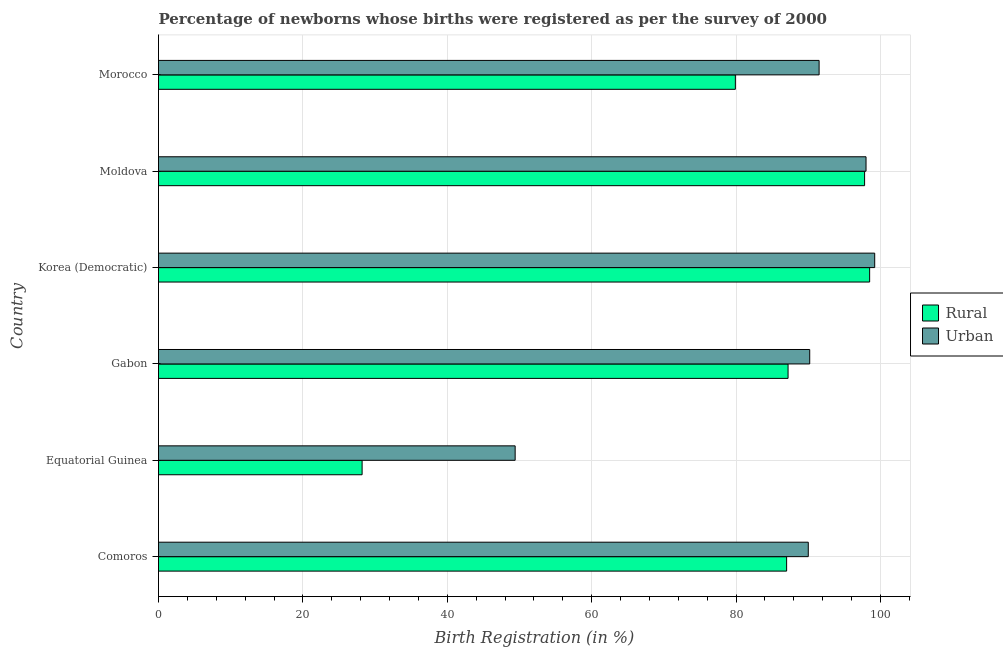How many different coloured bars are there?
Provide a succinct answer. 2. Are the number of bars per tick equal to the number of legend labels?
Keep it short and to the point. Yes. How many bars are there on the 3rd tick from the top?
Your response must be concise. 2. What is the label of the 5th group of bars from the top?
Provide a succinct answer. Equatorial Guinea. In how many cases, is the number of bars for a given country not equal to the number of legend labels?
Your answer should be very brief. 0. What is the rural birth registration in Moldova?
Offer a very short reply. 97.8. Across all countries, what is the maximum rural birth registration?
Your answer should be very brief. 98.5. Across all countries, what is the minimum rural birth registration?
Make the answer very short. 28.2. In which country was the urban birth registration maximum?
Offer a very short reply. Korea (Democratic). In which country was the urban birth registration minimum?
Make the answer very short. Equatorial Guinea. What is the total rural birth registration in the graph?
Provide a succinct answer. 478.6. What is the difference between the rural birth registration in Comoros and that in Gabon?
Provide a succinct answer. -0.2. What is the difference between the urban birth registration in Gabon and the rural birth registration in Morocco?
Give a very brief answer. 10.3. What is the average rural birth registration per country?
Offer a terse response. 79.77. What is the difference between the rural birth registration and urban birth registration in Comoros?
Ensure brevity in your answer.  -3. Is the rural birth registration in Gabon less than that in Moldova?
Your answer should be compact. Yes. Is the difference between the urban birth registration in Comoros and Morocco greater than the difference between the rural birth registration in Comoros and Morocco?
Offer a terse response. No. What is the difference between the highest and the lowest urban birth registration?
Make the answer very short. 49.8. Is the sum of the rural birth registration in Comoros and Gabon greater than the maximum urban birth registration across all countries?
Provide a succinct answer. Yes. What does the 2nd bar from the top in Moldova represents?
Make the answer very short. Rural. What does the 1st bar from the bottom in Moldova represents?
Your answer should be very brief. Rural. How many bars are there?
Provide a succinct answer. 12. How many countries are there in the graph?
Offer a very short reply. 6. Are the values on the major ticks of X-axis written in scientific E-notation?
Give a very brief answer. No. Does the graph contain any zero values?
Your answer should be compact. No. Does the graph contain grids?
Offer a very short reply. Yes. How many legend labels are there?
Give a very brief answer. 2. What is the title of the graph?
Keep it short and to the point. Percentage of newborns whose births were registered as per the survey of 2000. What is the label or title of the X-axis?
Offer a terse response. Birth Registration (in %). What is the Birth Registration (in %) in Urban in Comoros?
Keep it short and to the point. 90. What is the Birth Registration (in %) of Rural in Equatorial Guinea?
Give a very brief answer. 28.2. What is the Birth Registration (in %) of Urban in Equatorial Guinea?
Offer a terse response. 49.4. What is the Birth Registration (in %) in Rural in Gabon?
Provide a succinct answer. 87.2. What is the Birth Registration (in %) in Urban in Gabon?
Your response must be concise. 90.2. What is the Birth Registration (in %) of Rural in Korea (Democratic)?
Ensure brevity in your answer.  98.5. What is the Birth Registration (in %) of Urban in Korea (Democratic)?
Your answer should be compact. 99.2. What is the Birth Registration (in %) of Rural in Moldova?
Offer a terse response. 97.8. What is the Birth Registration (in %) in Urban in Moldova?
Make the answer very short. 98. What is the Birth Registration (in %) in Rural in Morocco?
Keep it short and to the point. 79.9. What is the Birth Registration (in %) of Urban in Morocco?
Ensure brevity in your answer.  91.5. Across all countries, what is the maximum Birth Registration (in %) of Rural?
Your answer should be very brief. 98.5. Across all countries, what is the maximum Birth Registration (in %) of Urban?
Provide a short and direct response. 99.2. Across all countries, what is the minimum Birth Registration (in %) in Rural?
Offer a terse response. 28.2. Across all countries, what is the minimum Birth Registration (in %) of Urban?
Your answer should be compact. 49.4. What is the total Birth Registration (in %) in Rural in the graph?
Give a very brief answer. 478.6. What is the total Birth Registration (in %) of Urban in the graph?
Your answer should be compact. 518.3. What is the difference between the Birth Registration (in %) in Rural in Comoros and that in Equatorial Guinea?
Your response must be concise. 58.8. What is the difference between the Birth Registration (in %) in Urban in Comoros and that in Equatorial Guinea?
Provide a succinct answer. 40.6. What is the difference between the Birth Registration (in %) in Urban in Comoros and that in Moldova?
Give a very brief answer. -8. What is the difference between the Birth Registration (in %) of Rural in Comoros and that in Morocco?
Your response must be concise. 7.1. What is the difference between the Birth Registration (in %) in Rural in Equatorial Guinea and that in Gabon?
Provide a short and direct response. -59. What is the difference between the Birth Registration (in %) in Urban in Equatorial Guinea and that in Gabon?
Give a very brief answer. -40.8. What is the difference between the Birth Registration (in %) of Rural in Equatorial Guinea and that in Korea (Democratic)?
Offer a very short reply. -70.3. What is the difference between the Birth Registration (in %) in Urban in Equatorial Guinea and that in Korea (Democratic)?
Offer a very short reply. -49.8. What is the difference between the Birth Registration (in %) of Rural in Equatorial Guinea and that in Moldova?
Ensure brevity in your answer.  -69.6. What is the difference between the Birth Registration (in %) of Urban in Equatorial Guinea and that in Moldova?
Keep it short and to the point. -48.6. What is the difference between the Birth Registration (in %) of Rural in Equatorial Guinea and that in Morocco?
Your answer should be very brief. -51.7. What is the difference between the Birth Registration (in %) of Urban in Equatorial Guinea and that in Morocco?
Make the answer very short. -42.1. What is the difference between the Birth Registration (in %) in Urban in Gabon and that in Korea (Democratic)?
Provide a succinct answer. -9. What is the difference between the Birth Registration (in %) of Rural in Gabon and that in Moldova?
Ensure brevity in your answer.  -10.6. What is the difference between the Birth Registration (in %) in Urban in Gabon and that in Moldova?
Offer a terse response. -7.8. What is the difference between the Birth Registration (in %) in Rural in Gabon and that in Morocco?
Offer a terse response. 7.3. What is the difference between the Birth Registration (in %) in Rural in Korea (Democratic) and that in Moldova?
Provide a succinct answer. 0.7. What is the difference between the Birth Registration (in %) of Rural in Korea (Democratic) and that in Morocco?
Make the answer very short. 18.6. What is the difference between the Birth Registration (in %) of Urban in Korea (Democratic) and that in Morocco?
Your answer should be very brief. 7.7. What is the difference between the Birth Registration (in %) of Rural in Moldova and that in Morocco?
Offer a very short reply. 17.9. What is the difference between the Birth Registration (in %) of Rural in Comoros and the Birth Registration (in %) of Urban in Equatorial Guinea?
Offer a terse response. 37.6. What is the difference between the Birth Registration (in %) in Rural in Comoros and the Birth Registration (in %) in Urban in Gabon?
Make the answer very short. -3.2. What is the difference between the Birth Registration (in %) of Rural in Equatorial Guinea and the Birth Registration (in %) of Urban in Gabon?
Provide a succinct answer. -62. What is the difference between the Birth Registration (in %) in Rural in Equatorial Guinea and the Birth Registration (in %) in Urban in Korea (Democratic)?
Give a very brief answer. -71. What is the difference between the Birth Registration (in %) in Rural in Equatorial Guinea and the Birth Registration (in %) in Urban in Moldova?
Your response must be concise. -69.8. What is the difference between the Birth Registration (in %) in Rural in Equatorial Guinea and the Birth Registration (in %) in Urban in Morocco?
Your answer should be compact. -63.3. What is the difference between the Birth Registration (in %) in Rural in Gabon and the Birth Registration (in %) in Urban in Korea (Democratic)?
Provide a succinct answer. -12. What is the difference between the Birth Registration (in %) in Rural in Gabon and the Birth Registration (in %) in Urban in Morocco?
Provide a short and direct response. -4.3. What is the difference between the Birth Registration (in %) of Rural in Korea (Democratic) and the Birth Registration (in %) of Urban in Moldova?
Provide a short and direct response. 0.5. What is the difference between the Birth Registration (in %) in Rural in Korea (Democratic) and the Birth Registration (in %) in Urban in Morocco?
Your answer should be very brief. 7. What is the average Birth Registration (in %) of Rural per country?
Keep it short and to the point. 79.77. What is the average Birth Registration (in %) in Urban per country?
Offer a very short reply. 86.38. What is the difference between the Birth Registration (in %) of Rural and Birth Registration (in %) of Urban in Comoros?
Give a very brief answer. -3. What is the difference between the Birth Registration (in %) of Rural and Birth Registration (in %) of Urban in Equatorial Guinea?
Offer a terse response. -21.2. What is the difference between the Birth Registration (in %) of Rural and Birth Registration (in %) of Urban in Gabon?
Offer a very short reply. -3. What is the difference between the Birth Registration (in %) in Rural and Birth Registration (in %) in Urban in Moldova?
Your response must be concise. -0.2. What is the difference between the Birth Registration (in %) in Rural and Birth Registration (in %) in Urban in Morocco?
Your answer should be compact. -11.6. What is the ratio of the Birth Registration (in %) of Rural in Comoros to that in Equatorial Guinea?
Make the answer very short. 3.09. What is the ratio of the Birth Registration (in %) of Urban in Comoros to that in Equatorial Guinea?
Offer a terse response. 1.82. What is the ratio of the Birth Registration (in %) in Rural in Comoros to that in Korea (Democratic)?
Keep it short and to the point. 0.88. What is the ratio of the Birth Registration (in %) of Urban in Comoros to that in Korea (Democratic)?
Offer a terse response. 0.91. What is the ratio of the Birth Registration (in %) in Rural in Comoros to that in Moldova?
Your answer should be compact. 0.89. What is the ratio of the Birth Registration (in %) of Urban in Comoros to that in Moldova?
Ensure brevity in your answer.  0.92. What is the ratio of the Birth Registration (in %) of Rural in Comoros to that in Morocco?
Your answer should be compact. 1.09. What is the ratio of the Birth Registration (in %) in Urban in Comoros to that in Morocco?
Offer a terse response. 0.98. What is the ratio of the Birth Registration (in %) of Rural in Equatorial Guinea to that in Gabon?
Provide a succinct answer. 0.32. What is the ratio of the Birth Registration (in %) of Urban in Equatorial Guinea to that in Gabon?
Keep it short and to the point. 0.55. What is the ratio of the Birth Registration (in %) of Rural in Equatorial Guinea to that in Korea (Democratic)?
Make the answer very short. 0.29. What is the ratio of the Birth Registration (in %) in Urban in Equatorial Guinea to that in Korea (Democratic)?
Your answer should be compact. 0.5. What is the ratio of the Birth Registration (in %) of Rural in Equatorial Guinea to that in Moldova?
Offer a terse response. 0.29. What is the ratio of the Birth Registration (in %) of Urban in Equatorial Guinea to that in Moldova?
Give a very brief answer. 0.5. What is the ratio of the Birth Registration (in %) in Rural in Equatorial Guinea to that in Morocco?
Provide a succinct answer. 0.35. What is the ratio of the Birth Registration (in %) of Urban in Equatorial Guinea to that in Morocco?
Offer a very short reply. 0.54. What is the ratio of the Birth Registration (in %) of Rural in Gabon to that in Korea (Democratic)?
Ensure brevity in your answer.  0.89. What is the ratio of the Birth Registration (in %) in Urban in Gabon to that in Korea (Democratic)?
Make the answer very short. 0.91. What is the ratio of the Birth Registration (in %) of Rural in Gabon to that in Moldova?
Provide a succinct answer. 0.89. What is the ratio of the Birth Registration (in %) in Urban in Gabon to that in Moldova?
Your response must be concise. 0.92. What is the ratio of the Birth Registration (in %) in Rural in Gabon to that in Morocco?
Make the answer very short. 1.09. What is the ratio of the Birth Registration (in %) in Urban in Gabon to that in Morocco?
Your answer should be compact. 0.99. What is the ratio of the Birth Registration (in %) in Urban in Korea (Democratic) to that in Moldova?
Ensure brevity in your answer.  1.01. What is the ratio of the Birth Registration (in %) in Rural in Korea (Democratic) to that in Morocco?
Your answer should be compact. 1.23. What is the ratio of the Birth Registration (in %) of Urban in Korea (Democratic) to that in Morocco?
Give a very brief answer. 1.08. What is the ratio of the Birth Registration (in %) of Rural in Moldova to that in Morocco?
Offer a very short reply. 1.22. What is the ratio of the Birth Registration (in %) in Urban in Moldova to that in Morocco?
Your answer should be very brief. 1.07. What is the difference between the highest and the second highest Birth Registration (in %) in Rural?
Provide a succinct answer. 0.7. What is the difference between the highest and the second highest Birth Registration (in %) of Urban?
Offer a very short reply. 1.2. What is the difference between the highest and the lowest Birth Registration (in %) of Rural?
Offer a very short reply. 70.3. What is the difference between the highest and the lowest Birth Registration (in %) in Urban?
Offer a very short reply. 49.8. 